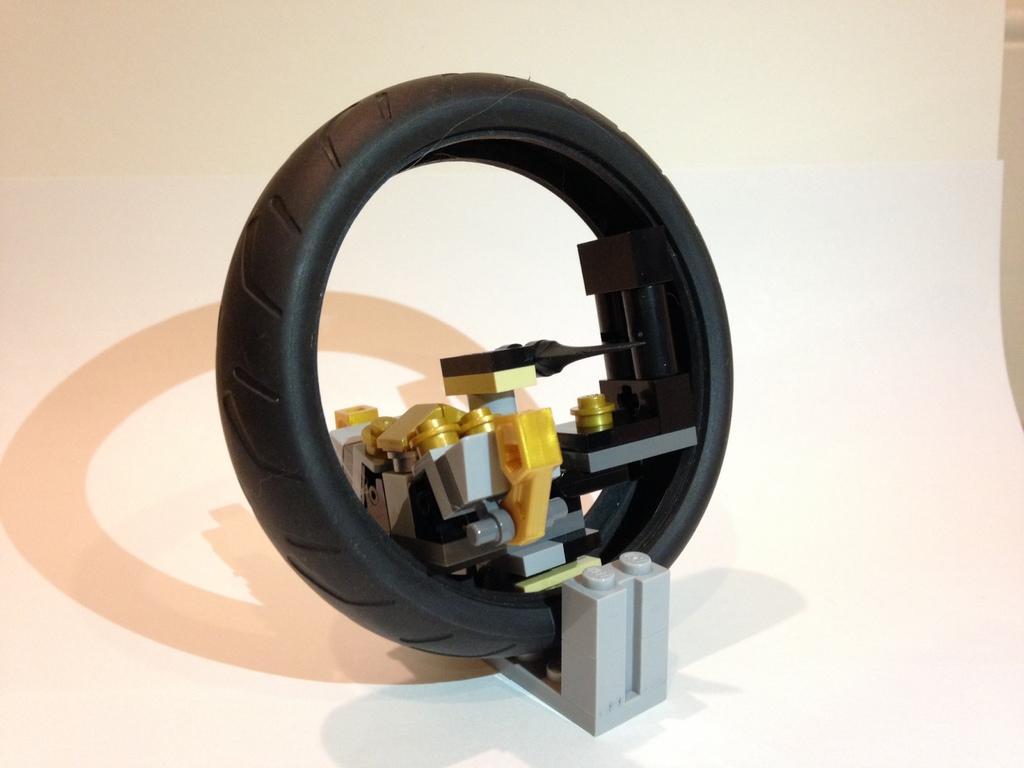Could you give a brief overview of what you see in this image? In this picture I can see a toy which looks like a tire. 